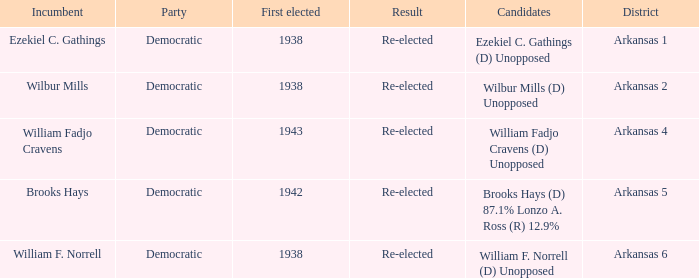What party did the incumbent of the Arkansas 6 district belong to?  Democratic. 